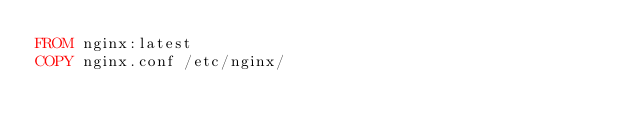<code> <loc_0><loc_0><loc_500><loc_500><_Dockerfile_>FROM nginx:latest
COPY nginx.conf /etc/nginx/
</code> 